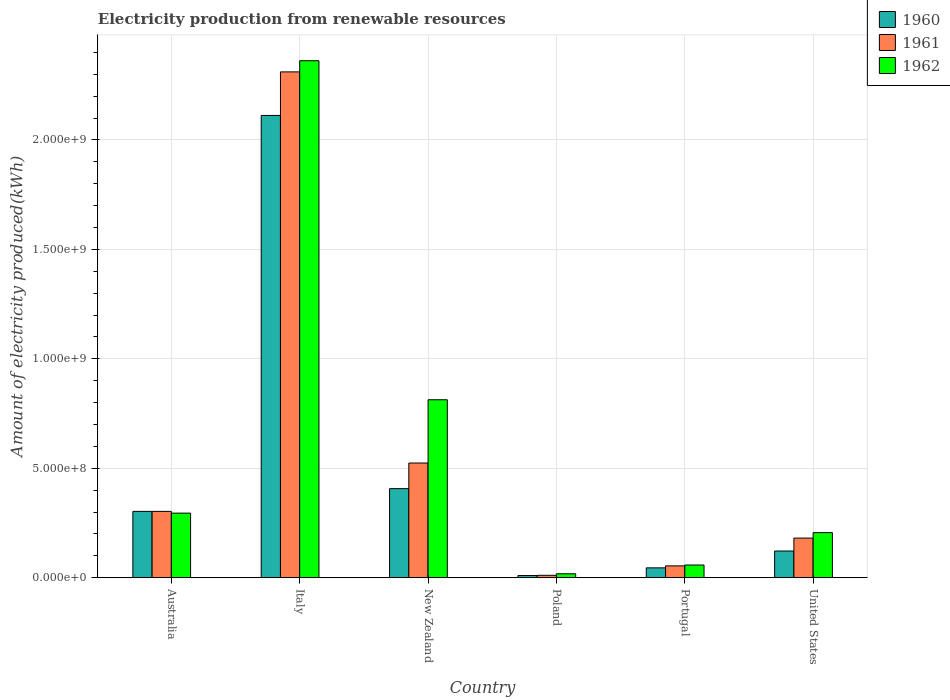How many different coloured bars are there?
Offer a terse response. 3. Are the number of bars on each tick of the X-axis equal?
Offer a very short reply. Yes. What is the label of the 1st group of bars from the left?
Your answer should be very brief. Australia. In how many cases, is the number of bars for a given country not equal to the number of legend labels?
Offer a very short reply. 0. What is the amount of electricity produced in 1961 in New Zealand?
Ensure brevity in your answer.  5.24e+08. Across all countries, what is the maximum amount of electricity produced in 1960?
Your answer should be very brief. 2.11e+09. Across all countries, what is the minimum amount of electricity produced in 1961?
Ensure brevity in your answer.  1.10e+07. What is the total amount of electricity produced in 1961 in the graph?
Your response must be concise. 3.38e+09. What is the difference between the amount of electricity produced in 1962 in New Zealand and that in Poland?
Give a very brief answer. 7.95e+08. What is the difference between the amount of electricity produced in 1962 in Italy and the amount of electricity produced in 1961 in Portugal?
Offer a terse response. 2.31e+09. What is the average amount of electricity produced in 1961 per country?
Make the answer very short. 5.64e+08. What is the difference between the amount of electricity produced of/in 1961 and amount of electricity produced of/in 1960 in Portugal?
Provide a succinct answer. 9.00e+06. In how many countries, is the amount of electricity produced in 1961 greater than 900000000 kWh?
Offer a terse response. 1. What is the ratio of the amount of electricity produced in 1962 in Poland to that in United States?
Offer a terse response. 0.09. What is the difference between the highest and the second highest amount of electricity produced in 1961?
Offer a terse response. 1.79e+09. What is the difference between the highest and the lowest amount of electricity produced in 1960?
Provide a succinct answer. 2.10e+09. In how many countries, is the amount of electricity produced in 1962 greater than the average amount of electricity produced in 1962 taken over all countries?
Offer a very short reply. 2. Is the sum of the amount of electricity produced in 1960 in Australia and Portugal greater than the maximum amount of electricity produced in 1961 across all countries?
Offer a very short reply. No. What does the 3rd bar from the right in Poland represents?
Your answer should be compact. 1960. Is it the case that in every country, the sum of the amount of electricity produced in 1961 and amount of electricity produced in 1960 is greater than the amount of electricity produced in 1962?
Provide a succinct answer. Yes. Are all the bars in the graph horizontal?
Your response must be concise. No. How many countries are there in the graph?
Your answer should be very brief. 6. What is the difference between two consecutive major ticks on the Y-axis?
Ensure brevity in your answer.  5.00e+08. Are the values on the major ticks of Y-axis written in scientific E-notation?
Give a very brief answer. Yes. What is the title of the graph?
Offer a terse response. Electricity production from renewable resources. What is the label or title of the X-axis?
Ensure brevity in your answer.  Country. What is the label or title of the Y-axis?
Your answer should be very brief. Amount of electricity produced(kWh). What is the Amount of electricity produced(kWh) in 1960 in Australia?
Your response must be concise. 3.03e+08. What is the Amount of electricity produced(kWh) of 1961 in Australia?
Ensure brevity in your answer.  3.03e+08. What is the Amount of electricity produced(kWh) of 1962 in Australia?
Your answer should be compact. 2.95e+08. What is the Amount of electricity produced(kWh) in 1960 in Italy?
Give a very brief answer. 2.11e+09. What is the Amount of electricity produced(kWh) in 1961 in Italy?
Provide a succinct answer. 2.31e+09. What is the Amount of electricity produced(kWh) in 1962 in Italy?
Your response must be concise. 2.36e+09. What is the Amount of electricity produced(kWh) in 1960 in New Zealand?
Give a very brief answer. 4.07e+08. What is the Amount of electricity produced(kWh) of 1961 in New Zealand?
Provide a short and direct response. 5.24e+08. What is the Amount of electricity produced(kWh) in 1962 in New Zealand?
Give a very brief answer. 8.13e+08. What is the Amount of electricity produced(kWh) of 1960 in Poland?
Provide a short and direct response. 1.00e+07. What is the Amount of electricity produced(kWh) of 1961 in Poland?
Provide a succinct answer. 1.10e+07. What is the Amount of electricity produced(kWh) in 1962 in Poland?
Give a very brief answer. 1.80e+07. What is the Amount of electricity produced(kWh) of 1960 in Portugal?
Provide a succinct answer. 4.50e+07. What is the Amount of electricity produced(kWh) of 1961 in Portugal?
Offer a terse response. 5.40e+07. What is the Amount of electricity produced(kWh) in 1962 in Portugal?
Keep it short and to the point. 5.80e+07. What is the Amount of electricity produced(kWh) in 1960 in United States?
Keep it short and to the point. 1.22e+08. What is the Amount of electricity produced(kWh) in 1961 in United States?
Ensure brevity in your answer.  1.81e+08. What is the Amount of electricity produced(kWh) in 1962 in United States?
Offer a very short reply. 2.06e+08. Across all countries, what is the maximum Amount of electricity produced(kWh) of 1960?
Make the answer very short. 2.11e+09. Across all countries, what is the maximum Amount of electricity produced(kWh) of 1961?
Give a very brief answer. 2.31e+09. Across all countries, what is the maximum Amount of electricity produced(kWh) of 1962?
Your answer should be compact. 2.36e+09. Across all countries, what is the minimum Amount of electricity produced(kWh) of 1960?
Keep it short and to the point. 1.00e+07. Across all countries, what is the minimum Amount of electricity produced(kWh) in 1961?
Provide a succinct answer. 1.10e+07. Across all countries, what is the minimum Amount of electricity produced(kWh) in 1962?
Provide a short and direct response. 1.80e+07. What is the total Amount of electricity produced(kWh) of 1960 in the graph?
Ensure brevity in your answer.  3.00e+09. What is the total Amount of electricity produced(kWh) of 1961 in the graph?
Provide a succinct answer. 3.38e+09. What is the total Amount of electricity produced(kWh) of 1962 in the graph?
Your answer should be compact. 3.75e+09. What is the difference between the Amount of electricity produced(kWh) in 1960 in Australia and that in Italy?
Offer a terse response. -1.81e+09. What is the difference between the Amount of electricity produced(kWh) in 1961 in Australia and that in Italy?
Give a very brief answer. -2.01e+09. What is the difference between the Amount of electricity produced(kWh) in 1962 in Australia and that in Italy?
Your answer should be very brief. -2.07e+09. What is the difference between the Amount of electricity produced(kWh) in 1960 in Australia and that in New Zealand?
Give a very brief answer. -1.04e+08. What is the difference between the Amount of electricity produced(kWh) in 1961 in Australia and that in New Zealand?
Your answer should be very brief. -2.21e+08. What is the difference between the Amount of electricity produced(kWh) of 1962 in Australia and that in New Zealand?
Give a very brief answer. -5.18e+08. What is the difference between the Amount of electricity produced(kWh) of 1960 in Australia and that in Poland?
Offer a very short reply. 2.93e+08. What is the difference between the Amount of electricity produced(kWh) in 1961 in Australia and that in Poland?
Your answer should be compact. 2.92e+08. What is the difference between the Amount of electricity produced(kWh) of 1962 in Australia and that in Poland?
Your answer should be compact. 2.77e+08. What is the difference between the Amount of electricity produced(kWh) in 1960 in Australia and that in Portugal?
Ensure brevity in your answer.  2.58e+08. What is the difference between the Amount of electricity produced(kWh) in 1961 in Australia and that in Portugal?
Your answer should be very brief. 2.49e+08. What is the difference between the Amount of electricity produced(kWh) in 1962 in Australia and that in Portugal?
Give a very brief answer. 2.37e+08. What is the difference between the Amount of electricity produced(kWh) in 1960 in Australia and that in United States?
Keep it short and to the point. 1.81e+08. What is the difference between the Amount of electricity produced(kWh) in 1961 in Australia and that in United States?
Give a very brief answer. 1.22e+08. What is the difference between the Amount of electricity produced(kWh) of 1962 in Australia and that in United States?
Offer a very short reply. 8.90e+07. What is the difference between the Amount of electricity produced(kWh) of 1960 in Italy and that in New Zealand?
Provide a short and direct response. 1.70e+09. What is the difference between the Amount of electricity produced(kWh) of 1961 in Italy and that in New Zealand?
Provide a succinct answer. 1.79e+09. What is the difference between the Amount of electricity produced(kWh) of 1962 in Italy and that in New Zealand?
Give a very brief answer. 1.55e+09. What is the difference between the Amount of electricity produced(kWh) in 1960 in Italy and that in Poland?
Give a very brief answer. 2.10e+09. What is the difference between the Amount of electricity produced(kWh) of 1961 in Italy and that in Poland?
Give a very brief answer. 2.30e+09. What is the difference between the Amount of electricity produced(kWh) of 1962 in Italy and that in Poland?
Keep it short and to the point. 2.34e+09. What is the difference between the Amount of electricity produced(kWh) of 1960 in Italy and that in Portugal?
Keep it short and to the point. 2.07e+09. What is the difference between the Amount of electricity produced(kWh) of 1961 in Italy and that in Portugal?
Give a very brief answer. 2.26e+09. What is the difference between the Amount of electricity produced(kWh) of 1962 in Italy and that in Portugal?
Your answer should be very brief. 2.30e+09. What is the difference between the Amount of electricity produced(kWh) of 1960 in Italy and that in United States?
Your answer should be very brief. 1.99e+09. What is the difference between the Amount of electricity produced(kWh) in 1961 in Italy and that in United States?
Provide a short and direct response. 2.13e+09. What is the difference between the Amount of electricity produced(kWh) in 1962 in Italy and that in United States?
Make the answer very short. 2.16e+09. What is the difference between the Amount of electricity produced(kWh) in 1960 in New Zealand and that in Poland?
Provide a succinct answer. 3.97e+08. What is the difference between the Amount of electricity produced(kWh) in 1961 in New Zealand and that in Poland?
Give a very brief answer. 5.13e+08. What is the difference between the Amount of electricity produced(kWh) of 1962 in New Zealand and that in Poland?
Offer a very short reply. 7.95e+08. What is the difference between the Amount of electricity produced(kWh) of 1960 in New Zealand and that in Portugal?
Your response must be concise. 3.62e+08. What is the difference between the Amount of electricity produced(kWh) of 1961 in New Zealand and that in Portugal?
Give a very brief answer. 4.70e+08. What is the difference between the Amount of electricity produced(kWh) in 1962 in New Zealand and that in Portugal?
Ensure brevity in your answer.  7.55e+08. What is the difference between the Amount of electricity produced(kWh) of 1960 in New Zealand and that in United States?
Provide a succinct answer. 2.85e+08. What is the difference between the Amount of electricity produced(kWh) of 1961 in New Zealand and that in United States?
Your answer should be compact. 3.43e+08. What is the difference between the Amount of electricity produced(kWh) of 1962 in New Zealand and that in United States?
Make the answer very short. 6.07e+08. What is the difference between the Amount of electricity produced(kWh) of 1960 in Poland and that in Portugal?
Ensure brevity in your answer.  -3.50e+07. What is the difference between the Amount of electricity produced(kWh) of 1961 in Poland and that in Portugal?
Your answer should be compact. -4.30e+07. What is the difference between the Amount of electricity produced(kWh) of 1962 in Poland and that in Portugal?
Ensure brevity in your answer.  -4.00e+07. What is the difference between the Amount of electricity produced(kWh) in 1960 in Poland and that in United States?
Provide a short and direct response. -1.12e+08. What is the difference between the Amount of electricity produced(kWh) of 1961 in Poland and that in United States?
Your answer should be compact. -1.70e+08. What is the difference between the Amount of electricity produced(kWh) of 1962 in Poland and that in United States?
Make the answer very short. -1.88e+08. What is the difference between the Amount of electricity produced(kWh) in 1960 in Portugal and that in United States?
Ensure brevity in your answer.  -7.70e+07. What is the difference between the Amount of electricity produced(kWh) in 1961 in Portugal and that in United States?
Provide a succinct answer. -1.27e+08. What is the difference between the Amount of electricity produced(kWh) of 1962 in Portugal and that in United States?
Your answer should be very brief. -1.48e+08. What is the difference between the Amount of electricity produced(kWh) of 1960 in Australia and the Amount of electricity produced(kWh) of 1961 in Italy?
Give a very brief answer. -2.01e+09. What is the difference between the Amount of electricity produced(kWh) of 1960 in Australia and the Amount of electricity produced(kWh) of 1962 in Italy?
Give a very brief answer. -2.06e+09. What is the difference between the Amount of electricity produced(kWh) of 1961 in Australia and the Amount of electricity produced(kWh) of 1962 in Italy?
Offer a very short reply. -2.06e+09. What is the difference between the Amount of electricity produced(kWh) in 1960 in Australia and the Amount of electricity produced(kWh) in 1961 in New Zealand?
Provide a succinct answer. -2.21e+08. What is the difference between the Amount of electricity produced(kWh) in 1960 in Australia and the Amount of electricity produced(kWh) in 1962 in New Zealand?
Offer a terse response. -5.10e+08. What is the difference between the Amount of electricity produced(kWh) in 1961 in Australia and the Amount of electricity produced(kWh) in 1962 in New Zealand?
Your answer should be compact. -5.10e+08. What is the difference between the Amount of electricity produced(kWh) of 1960 in Australia and the Amount of electricity produced(kWh) of 1961 in Poland?
Provide a succinct answer. 2.92e+08. What is the difference between the Amount of electricity produced(kWh) of 1960 in Australia and the Amount of electricity produced(kWh) of 1962 in Poland?
Ensure brevity in your answer.  2.85e+08. What is the difference between the Amount of electricity produced(kWh) of 1961 in Australia and the Amount of electricity produced(kWh) of 1962 in Poland?
Offer a very short reply. 2.85e+08. What is the difference between the Amount of electricity produced(kWh) of 1960 in Australia and the Amount of electricity produced(kWh) of 1961 in Portugal?
Offer a terse response. 2.49e+08. What is the difference between the Amount of electricity produced(kWh) of 1960 in Australia and the Amount of electricity produced(kWh) of 1962 in Portugal?
Your response must be concise. 2.45e+08. What is the difference between the Amount of electricity produced(kWh) in 1961 in Australia and the Amount of electricity produced(kWh) in 1962 in Portugal?
Your answer should be compact. 2.45e+08. What is the difference between the Amount of electricity produced(kWh) in 1960 in Australia and the Amount of electricity produced(kWh) in 1961 in United States?
Your answer should be compact. 1.22e+08. What is the difference between the Amount of electricity produced(kWh) of 1960 in Australia and the Amount of electricity produced(kWh) of 1962 in United States?
Keep it short and to the point. 9.70e+07. What is the difference between the Amount of electricity produced(kWh) of 1961 in Australia and the Amount of electricity produced(kWh) of 1962 in United States?
Keep it short and to the point. 9.70e+07. What is the difference between the Amount of electricity produced(kWh) of 1960 in Italy and the Amount of electricity produced(kWh) of 1961 in New Zealand?
Provide a short and direct response. 1.59e+09. What is the difference between the Amount of electricity produced(kWh) in 1960 in Italy and the Amount of electricity produced(kWh) in 1962 in New Zealand?
Provide a succinct answer. 1.30e+09. What is the difference between the Amount of electricity produced(kWh) in 1961 in Italy and the Amount of electricity produced(kWh) in 1962 in New Zealand?
Offer a very short reply. 1.50e+09. What is the difference between the Amount of electricity produced(kWh) of 1960 in Italy and the Amount of electricity produced(kWh) of 1961 in Poland?
Give a very brief answer. 2.10e+09. What is the difference between the Amount of electricity produced(kWh) of 1960 in Italy and the Amount of electricity produced(kWh) of 1962 in Poland?
Provide a succinct answer. 2.09e+09. What is the difference between the Amount of electricity produced(kWh) in 1961 in Italy and the Amount of electricity produced(kWh) in 1962 in Poland?
Offer a very short reply. 2.29e+09. What is the difference between the Amount of electricity produced(kWh) of 1960 in Italy and the Amount of electricity produced(kWh) of 1961 in Portugal?
Provide a short and direct response. 2.06e+09. What is the difference between the Amount of electricity produced(kWh) in 1960 in Italy and the Amount of electricity produced(kWh) in 1962 in Portugal?
Keep it short and to the point. 2.05e+09. What is the difference between the Amount of electricity produced(kWh) in 1961 in Italy and the Amount of electricity produced(kWh) in 1962 in Portugal?
Ensure brevity in your answer.  2.25e+09. What is the difference between the Amount of electricity produced(kWh) of 1960 in Italy and the Amount of electricity produced(kWh) of 1961 in United States?
Offer a very short reply. 1.93e+09. What is the difference between the Amount of electricity produced(kWh) of 1960 in Italy and the Amount of electricity produced(kWh) of 1962 in United States?
Offer a terse response. 1.91e+09. What is the difference between the Amount of electricity produced(kWh) in 1961 in Italy and the Amount of electricity produced(kWh) in 1962 in United States?
Provide a succinct answer. 2.10e+09. What is the difference between the Amount of electricity produced(kWh) in 1960 in New Zealand and the Amount of electricity produced(kWh) in 1961 in Poland?
Ensure brevity in your answer.  3.96e+08. What is the difference between the Amount of electricity produced(kWh) of 1960 in New Zealand and the Amount of electricity produced(kWh) of 1962 in Poland?
Keep it short and to the point. 3.89e+08. What is the difference between the Amount of electricity produced(kWh) in 1961 in New Zealand and the Amount of electricity produced(kWh) in 1962 in Poland?
Keep it short and to the point. 5.06e+08. What is the difference between the Amount of electricity produced(kWh) of 1960 in New Zealand and the Amount of electricity produced(kWh) of 1961 in Portugal?
Offer a terse response. 3.53e+08. What is the difference between the Amount of electricity produced(kWh) of 1960 in New Zealand and the Amount of electricity produced(kWh) of 1962 in Portugal?
Your answer should be very brief. 3.49e+08. What is the difference between the Amount of electricity produced(kWh) in 1961 in New Zealand and the Amount of electricity produced(kWh) in 1962 in Portugal?
Make the answer very short. 4.66e+08. What is the difference between the Amount of electricity produced(kWh) of 1960 in New Zealand and the Amount of electricity produced(kWh) of 1961 in United States?
Give a very brief answer. 2.26e+08. What is the difference between the Amount of electricity produced(kWh) in 1960 in New Zealand and the Amount of electricity produced(kWh) in 1962 in United States?
Offer a very short reply. 2.01e+08. What is the difference between the Amount of electricity produced(kWh) of 1961 in New Zealand and the Amount of electricity produced(kWh) of 1962 in United States?
Ensure brevity in your answer.  3.18e+08. What is the difference between the Amount of electricity produced(kWh) of 1960 in Poland and the Amount of electricity produced(kWh) of 1961 in Portugal?
Your response must be concise. -4.40e+07. What is the difference between the Amount of electricity produced(kWh) in 1960 in Poland and the Amount of electricity produced(kWh) in 1962 in Portugal?
Offer a very short reply. -4.80e+07. What is the difference between the Amount of electricity produced(kWh) in 1961 in Poland and the Amount of electricity produced(kWh) in 1962 in Portugal?
Make the answer very short. -4.70e+07. What is the difference between the Amount of electricity produced(kWh) in 1960 in Poland and the Amount of electricity produced(kWh) in 1961 in United States?
Offer a terse response. -1.71e+08. What is the difference between the Amount of electricity produced(kWh) in 1960 in Poland and the Amount of electricity produced(kWh) in 1962 in United States?
Your response must be concise. -1.96e+08. What is the difference between the Amount of electricity produced(kWh) in 1961 in Poland and the Amount of electricity produced(kWh) in 1962 in United States?
Offer a terse response. -1.95e+08. What is the difference between the Amount of electricity produced(kWh) of 1960 in Portugal and the Amount of electricity produced(kWh) of 1961 in United States?
Ensure brevity in your answer.  -1.36e+08. What is the difference between the Amount of electricity produced(kWh) of 1960 in Portugal and the Amount of electricity produced(kWh) of 1962 in United States?
Ensure brevity in your answer.  -1.61e+08. What is the difference between the Amount of electricity produced(kWh) in 1961 in Portugal and the Amount of electricity produced(kWh) in 1962 in United States?
Ensure brevity in your answer.  -1.52e+08. What is the average Amount of electricity produced(kWh) in 1960 per country?
Provide a short and direct response. 5.00e+08. What is the average Amount of electricity produced(kWh) of 1961 per country?
Provide a short and direct response. 5.64e+08. What is the average Amount of electricity produced(kWh) of 1962 per country?
Ensure brevity in your answer.  6.25e+08. What is the difference between the Amount of electricity produced(kWh) in 1961 and Amount of electricity produced(kWh) in 1962 in Australia?
Keep it short and to the point. 8.00e+06. What is the difference between the Amount of electricity produced(kWh) in 1960 and Amount of electricity produced(kWh) in 1961 in Italy?
Offer a very short reply. -1.99e+08. What is the difference between the Amount of electricity produced(kWh) in 1960 and Amount of electricity produced(kWh) in 1962 in Italy?
Provide a succinct answer. -2.50e+08. What is the difference between the Amount of electricity produced(kWh) in 1961 and Amount of electricity produced(kWh) in 1962 in Italy?
Keep it short and to the point. -5.10e+07. What is the difference between the Amount of electricity produced(kWh) of 1960 and Amount of electricity produced(kWh) of 1961 in New Zealand?
Give a very brief answer. -1.17e+08. What is the difference between the Amount of electricity produced(kWh) of 1960 and Amount of electricity produced(kWh) of 1962 in New Zealand?
Your response must be concise. -4.06e+08. What is the difference between the Amount of electricity produced(kWh) in 1961 and Amount of electricity produced(kWh) in 1962 in New Zealand?
Provide a short and direct response. -2.89e+08. What is the difference between the Amount of electricity produced(kWh) in 1960 and Amount of electricity produced(kWh) in 1962 in Poland?
Ensure brevity in your answer.  -8.00e+06. What is the difference between the Amount of electricity produced(kWh) of 1961 and Amount of electricity produced(kWh) of 1962 in Poland?
Make the answer very short. -7.00e+06. What is the difference between the Amount of electricity produced(kWh) of 1960 and Amount of electricity produced(kWh) of 1961 in Portugal?
Provide a short and direct response. -9.00e+06. What is the difference between the Amount of electricity produced(kWh) of 1960 and Amount of electricity produced(kWh) of 1962 in Portugal?
Ensure brevity in your answer.  -1.30e+07. What is the difference between the Amount of electricity produced(kWh) of 1960 and Amount of electricity produced(kWh) of 1961 in United States?
Ensure brevity in your answer.  -5.90e+07. What is the difference between the Amount of electricity produced(kWh) of 1960 and Amount of electricity produced(kWh) of 1962 in United States?
Offer a terse response. -8.40e+07. What is the difference between the Amount of electricity produced(kWh) in 1961 and Amount of electricity produced(kWh) in 1962 in United States?
Offer a very short reply. -2.50e+07. What is the ratio of the Amount of electricity produced(kWh) in 1960 in Australia to that in Italy?
Keep it short and to the point. 0.14. What is the ratio of the Amount of electricity produced(kWh) in 1961 in Australia to that in Italy?
Give a very brief answer. 0.13. What is the ratio of the Amount of electricity produced(kWh) in 1962 in Australia to that in Italy?
Give a very brief answer. 0.12. What is the ratio of the Amount of electricity produced(kWh) of 1960 in Australia to that in New Zealand?
Your response must be concise. 0.74. What is the ratio of the Amount of electricity produced(kWh) of 1961 in Australia to that in New Zealand?
Your response must be concise. 0.58. What is the ratio of the Amount of electricity produced(kWh) in 1962 in Australia to that in New Zealand?
Your answer should be very brief. 0.36. What is the ratio of the Amount of electricity produced(kWh) in 1960 in Australia to that in Poland?
Provide a short and direct response. 30.3. What is the ratio of the Amount of electricity produced(kWh) of 1961 in Australia to that in Poland?
Make the answer very short. 27.55. What is the ratio of the Amount of electricity produced(kWh) in 1962 in Australia to that in Poland?
Provide a succinct answer. 16.39. What is the ratio of the Amount of electricity produced(kWh) of 1960 in Australia to that in Portugal?
Ensure brevity in your answer.  6.73. What is the ratio of the Amount of electricity produced(kWh) in 1961 in Australia to that in Portugal?
Your response must be concise. 5.61. What is the ratio of the Amount of electricity produced(kWh) of 1962 in Australia to that in Portugal?
Your answer should be compact. 5.09. What is the ratio of the Amount of electricity produced(kWh) in 1960 in Australia to that in United States?
Your response must be concise. 2.48. What is the ratio of the Amount of electricity produced(kWh) of 1961 in Australia to that in United States?
Keep it short and to the point. 1.67. What is the ratio of the Amount of electricity produced(kWh) of 1962 in Australia to that in United States?
Your answer should be very brief. 1.43. What is the ratio of the Amount of electricity produced(kWh) of 1960 in Italy to that in New Zealand?
Ensure brevity in your answer.  5.19. What is the ratio of the Amount of electricity produced(kWh) of 1961 in Italy to that in New Zealand?
Provide a short and direct response. 4.41. What is the ratio of the Amount of electricity produced(kWh) of 1962 in Italy to that in New Zealand?
Keep it short and to the point. 2.91. What is the ratio of the Amount of electricity produced(kWh) of 1960 in Italy to that in Poland?
Keep it short and to the point. 211.2. What is the ratio of the Amount of electricity produced(kWh) of 1961 in Italy to that in Poland?
Give a very brief answer. 210.09. What is the ratio of the Amount of electricity produced(kWh) of 1962 in Italy to that in Poland?
Provide a succinct answer. 131.22. What is the ratio of the Amount of electricity produced(kWh) in 1960 in Italy to that in Portugal?
Offer a very short reply. 46.93. What is the ratio of the Amount of electricity produced(kWh) of 1961 in Italy to that in Portugal?
Offer a terse response. 42.8. What is the ratio of the Amount of electricity produced(kWh) in 1962 in Italy to that in Portugal?
Make the answer very short. 40.72. What is the ratio of the Amount of electricity produced(kWh) in 1960 in Italy to that in United States?
Your response must be concise. 17.31. What is the ratio of the Amount of electricity produced(kWh) of 1961 in Italy to that in United States?
Make the answer very short. 12.77. What is the ratio of the Amount of electricity produced(kWh) of 1962 in Italy to that in United States?
Offer a very short reply. 11.47. What is the ratio of the Amount of electricity produced(kWh) of 1960 in New Zealand to that in Poland?
Your response must be concise. 40.7. What is the ratio of the Amount of electricity produced(kWh) of 1961 in New Zealand to that in Poland?
Give a very brief answer. 47.64. What is the ratio of the Amount of electricity produced(kWh) in 1962 in New Zealand to that in Poland?
Ensure brevity in your answer.  45.17. What is the ratio of the Amount of electricity produced(kWh) in 1960 in New Zealand to that in Portugal?
Your answer should be compact. 9.04. What is the ratio of the Amount of electricity produced(kWh) in 1961 in New Zealand to that in Portugal?
Offer a very short reply. 9.7. What is the ratio of the Amount of electricity produced(kWh) of 1962 in New Zealand to that in Portugal?
Keep it short and to the point. 14.02. What is the ratio of the Amount of electricity produced(kWh) of 1960 in New Zealand to that in United States?
Provide a succinct answer. 3.34. What is the ratio of the Amount of electricity produced(kWh) in 1961 in New Zealand to that in United States?
Offer a terse response. 2.9. What is the ratio of the Amount of electricity produced(kWh) of 1962 in New Zealand to that in United States?
Provide a short and direct response. 3.95. What is the ratio of the Amount of electricity produced(kWh) of 1960 in Poland to that in Portugal?
Ensure brevity in your answer.  0.22. What is the ratio of the Amount of electricity produced(kWh) in 1961 in Poland to that in Portugal?
Offer a very short reply. 0.2. What is the ratio of the Amount of electricity produced(kWh) of 1962 in Poland to that in Portugal?
Your answer should be very brief. 0.31. What is the ratio of the Amount of electricity produced(kWh) in 1960 in Poland to that in United States?
Make the answer very short. 0.08. What is the ratio of the Amount of electricity produced(kWh) of 1961 in Poland to that in United States?
Your answer should be compact. 0.06. What is the ratio of the Amount of electricity produced(kWh) in 1962 in Poland to that in United States?
Your answer should be compact. 0.09. What is the ratio of the Amount of electricity produced(kWh) of 1960 in Portugal to that in United States?
Make the answer very short. 0.37. What is the ratio of the Amount of electricity produced(kWh) of 1961 in Portugal to that in United States?
Make the answer very short. 0.3. What is the ratio of the Amount of electricity produced(kWh) of 1962 in Portugal to that in United States?
Your response must be concise. 0.28. What is the difference between the highest and the second highest Amount of electricity produced(kWh) in 1960?
Offer a terse response. 1.70e+09. What is the difference between the highest and the second highest Amount of electricity produced(kWh) of 1961?
Ensure brevity in your answer.  1.79e+09. What is the difference between the highest and the second highest Amount of electricity produced(kWh) of 1962?
Keep it short and to the point. 1.55e+09. What is the difference between the highest and the lowest Amount of electricity produced(kWh) of 1960?
Keep it short and to the point. 2.10e+09. What is the difference between the highest and the lowest Amount of electricity produced(kWh) in 1961?
Make the answer very short. 2.30e+09. What is the difference between the highest and the lowest Amount of electricity produced(kWh) in 1962?
Offer a terse response. 2.34e+09. 